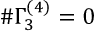<formula> <loc_0><loc_0><loc_500><loc_500>\# \Gamma _ { 3 } ^ { ( 4 ) } = 0</formula> 